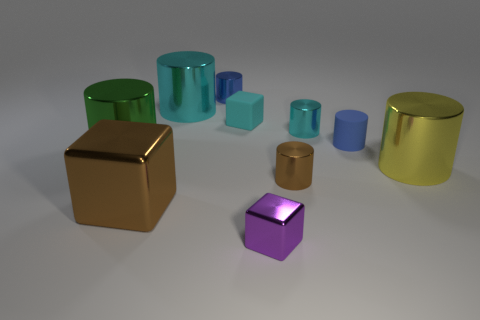Subtract all cyan cylinders. How many cylinders are left? 5 Subtract all large cylinders. How many cylinders are left? 4 Subtract all red cylinders. Subtract all green spheres. How many cylinders are left? 7 Subtract all cylinders. How many objects are left? 3 Add 6 tiny cubes. How many tiny cubes are left? 8 Add 3 green shiny cylinders. How many green shiny cylinders exist? 4 Subtract 0 blue spheres. How many objects are left? 10 Subtract all yellow shiny objects. Subtract all purple blocks. How many objects are left? 8 